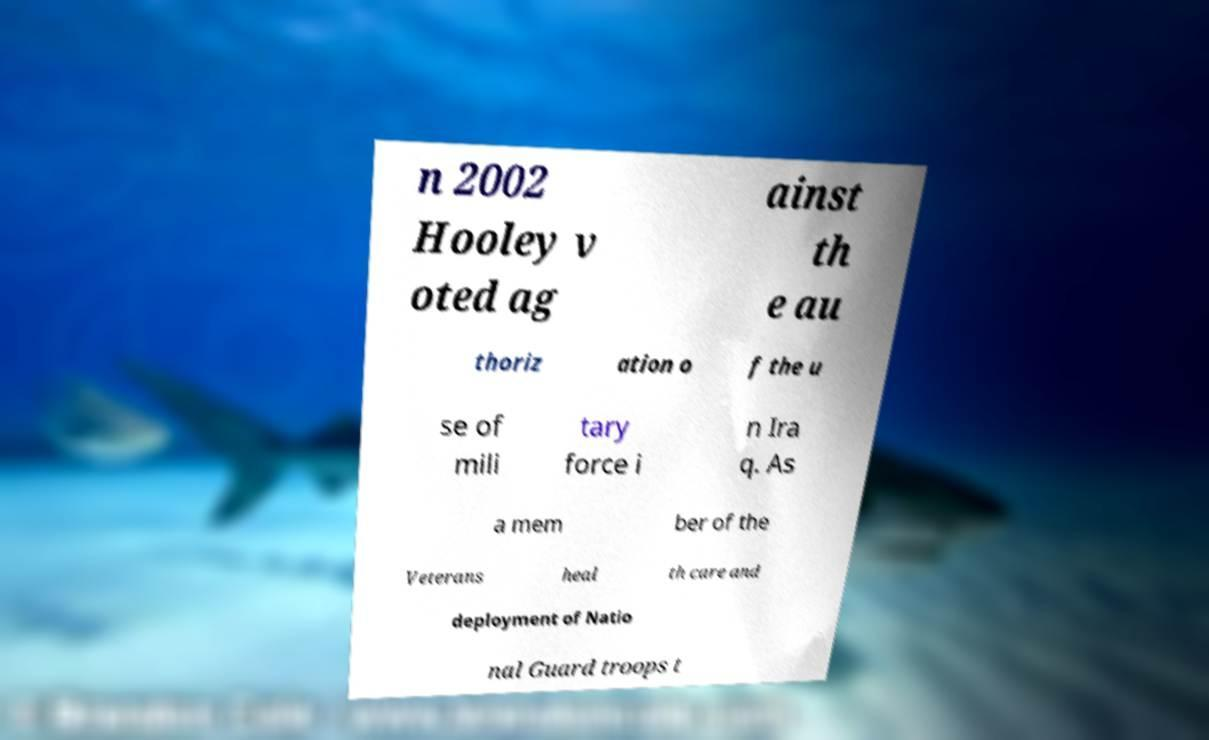For documentation purposes, I need the text within this image transcribed. Could you provide that? n 2002 Hooley v oted ag ainst th e au thoriz ation o f the u se of mili tary force i n Ira q. As a mem ber of the Veterans heal th care and deployment of Natio nal Guard troops t 